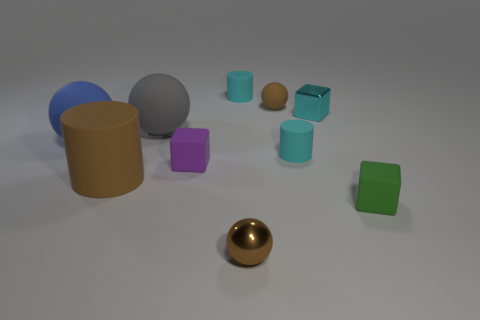Is the number of metallic blocks to the right of the brown matte ball greater than the number of blue things that are on the right side of the blue ball?
Ensure brevity in your answer.  Yes. What material is the cylinder that is in front of the cyan rubber thing in front of the small cylinder behind the big blue thing?
Provide a succinct answer. Rubber. Do the tiny cyan thing in front of the blue rubber thing and the brown matte object behind the large gray rubber ball have the same shape?
Your answer should be very brief. No. Are there any gray things of the same size as the cyan shiny thing?
Provide a short and direct response. No. What number of blue objects are tiny balls or metallic things?
Keep it short and to the point. 0. How many small metallic things are the same color as the tiny metallic block?
Offer a terse response. 0. Is there any other thing that is the same shape as the purple matte object?
Give a very brief answer. Yes. What number of cylinders are big blue rubber objects or green rubber objects?
Offer a terse response. 0. There is a rubber cylinder behind the blue thing; what is its color?
Give a very brief answer. Cyan. What is the shape of the purple matte object that is the same size as the cyan cube?
Offer a very short reply. Cube. 